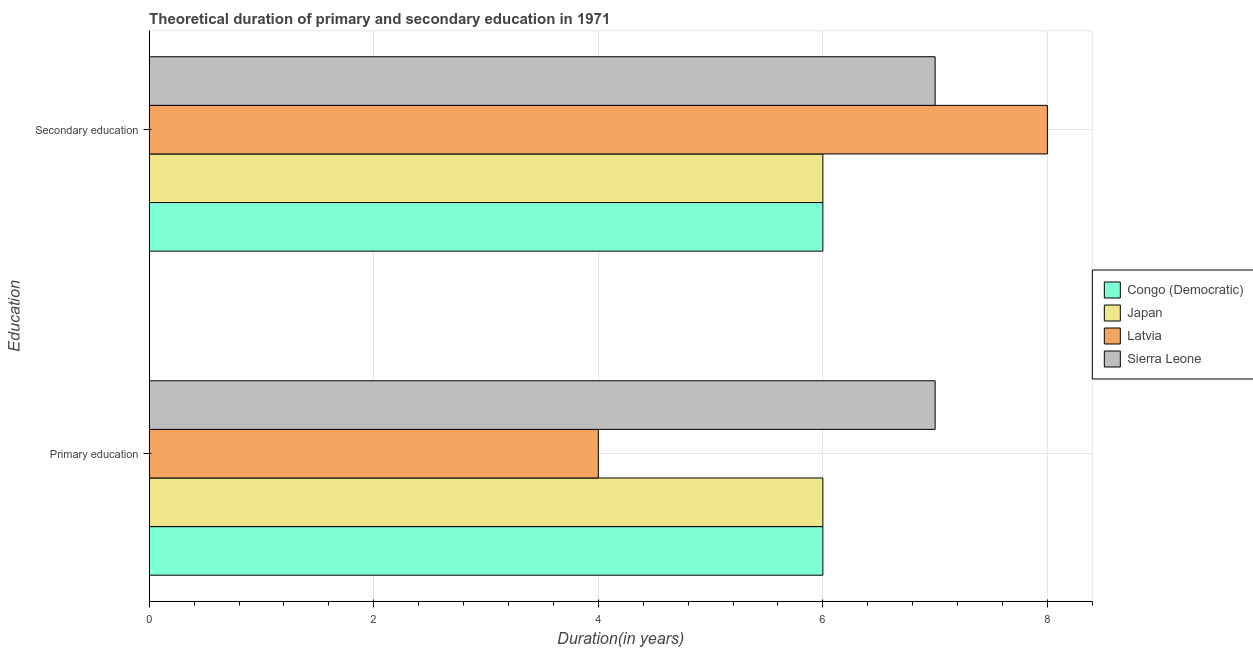Are the number of bars per tick equal to the number of legend labels?
Your answer should be very brief. Yes. Across all countries, what is the maximum duration of primary education?
Provide a succinct answer. 7. Across all countries, what is the minimum duration of primary education?
Offer a terse response. 4. In which country was the duration of primary education maximum?
Keep it short and to the point. Sierra Leone. In which country was the duration of primary education minimum?
Ensure brevity in your answer.  Latvia. What is the total duration of secondary education in the graph?
Your answer should be very brief. 27. What is the difference between the duration of primary education in Japan and that in Congo (Democratic)?
Your response must be concise. 0. What is the difference between the duration of primary education in Congo (Democratic) and the duration of secondary education in Japan?
Provide a succinct answer. 0. What is the average duration of primary education per country?
Give a very brief answer. 5.75. What is the ratio of the duration of primary education in Latvia to that in Japan?
Offer a terse response. 0.67. Is the duration of primary education in Latvia less than that in Sierra Leone?
Your answer should be very brief. Yes. In how many countries, is the duration of secondary education greater than the average duration of secondary education taken over all countries?
Your answer should be very brief. 2. What does the 1st bar from the top in Primary education represents?
Make the answer very short. Sierra Leone. What does the 4th bar from the bottom in Secondary education represents?
Provide a short and direct response. Sierra Leone. How many bars are there?
Offer a terse response. 8. Are all the bars in the graph horizontal?
Give a very brief answer. Yes. What is the difference between two consecutive major ticks on the X-axis?
Give a very brief answer. 2. Are the values on the major ticks of X-axis written in scientific E-notation?
Keep it short and to the point. No. How are the legend labels stacked?
Your answer should be very brief. Vertical. What is the title of the graph?
Give a very brief answer. Theoretical duration of primary and secondary education in 1971. What is the label or title of the X-axis?
Your response must be concise. Duration(in years). What is the label or title of the Y-axis?
Provide a short and direct response. Education. What is the Duration(in years) of Japan in Primary education?
Provide a short and direct response. 6. What is the Duration(in years) in Congo (Democratic) in Secondary education?
Provide a succinct answer. 6. Across all Education, what is the maximum Duration(in years) in Congo (Democratic)?
Your response must be concise. 6. Across all Education, what is the maximum Duration(in years) in Japan?
Make the answer very short. 6. Across all Education, what is the maximum Duration(in years) in Latvia?
Offer a terse response. 8. Across all Education, what is the maximum Duration(in years) in Sierra Leone?
Ensure brevity in your answer.  7. Across all Education, what is the minimum Duration(in years) of Latvia?
Your answer should be very brief. 4. Across all Education, what is the minimum Duration(in years) of Sierra Leone?
Keep it short and to the point. 7. What is the total Duration(in years) in Congo (Democratic) in the graph?
Offer a terse response. 12. What is the total Duration(in years) in Japan in the graph?
Ensure brevity in your answer.  12. What is the difference between the Duration(in years) of Congo (Democratic) in Primary education and that in Secondary education?
Provide a succinct answer. 0. What is the difference between the Duration(in years) in Sierra Leone in Primary education and that in Secondary education?
Your response must be concise. 0. What is the difference between the Duration(in years) of Congo (Democratic) in Primary education and the Duration(in years) of Japan in Secondary education?
Keep it short and to the point. 0. What is the difference between the Duration(in years) of Congo (Democratic) in Primary education and the Duration(in years) of Latvia in Secondary education?
Offer a very short reply. -2. What is the difference between the Duration(in years) of Congo (Democratic) in Primary education and the Duration(in years) of Sierra Leone in Secondary education?
Offer a terse response. -1. What is the average Duration(in years) of Latvia per Education?
Offer a terse response. 6. What is the average Duration(in years) of Sierra Leone per Education?
Give a very brief answer. 7. What is the difference between the Duration(in years) of Congo (Democratic) and Duration(in years) of Japan in Primary education?
Offer a very short reply. 0. What is the difference between the Duration(in years) in Congo (Democratic) and Duration(in years) in Latvia in Primary education?
Offer a very short reply. 2. What is the difference between the Duration(in years) of Congo (Democratic) and Duration(in years) of Sierra Leone in Primary education?
Your answer should be very brief. -1. What is the difference between the Duration(in years) of Japan and Duration(in years) of Sierra Leone in Primary education?
Your answer should be compact. -1. What is the difference between the Duration(in years) of Latvia and Duration(in years) of Sierra Leone in Primary education?
Provide a succinct answer. -3. What is the difference between the Duration(in years) in Congo (Democratic) and Duration(in years) in Japan in Secondary education?
Provide a succinct answer. 0. What is the difference between the Duration(in years) in Japan and Duration(in years) in Latvia in Secondary education?
Ensure brevity in your answer.  -2. What is the difference between the Duration(in years) of Japan and Duration(in years) of Sierra Leone in Secondary education?
Ensure brevity in your answer.  -1. What is the ratio of the Duration(in years) in Congo (Democratic) in Primary education to that in Secondary education?
Provide a succinct answer. 1. What is the ratio of the Duration(in years) in Latvia in Primary education to that in Secondary education?
Give a very brief answer. 0.5. What is the ratio of the Duration(in years) in Sierra Leone in Primary education to that in Secondary education?
Offer a terse response. 1. What is the difference between the highest and the second highest Duration(in years) of Congo (Democratic)?
Your answer should be compact. 0. What is the difference between the highest and the second highest Duration(in years) of Japan?
Keep it short and to the point. 0. What is the difference between the highest and the second highest Duration(in years) in Sierra Leone?
Offer a very short reply. 0. What is the difference between the highest and the lowest Duration(in years) of Congo (Democratic)?
Offer a very short reply. 0. What is the difference between the highest and the lowest Duration(in years) in Japan?
Your answer should be compact. 0. 